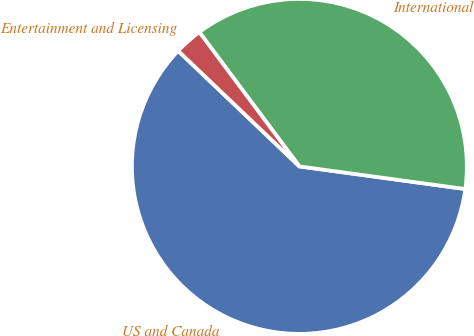<chart> <loc_0><loc_0><loc_500><loc_500><pie_chart><fcel>US and Canada<fcel>International<fcel>Entertainment and Licensing<nl><fcel>59.96%<fcel>37.35%<fcel>2.69%<nl></chart> 